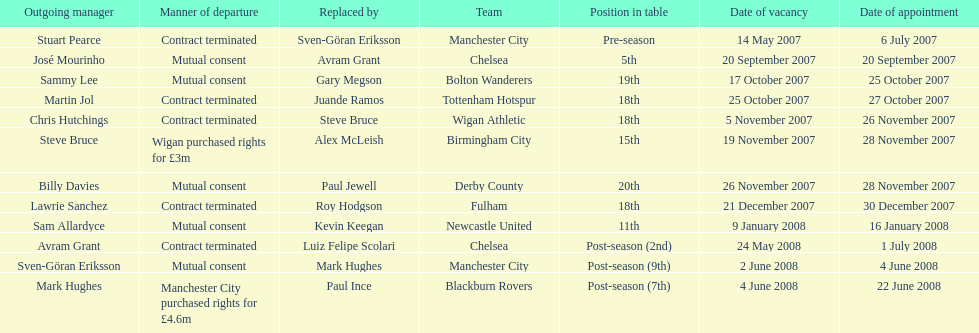How many outgoing managers were appointed in november 2007? 3. 